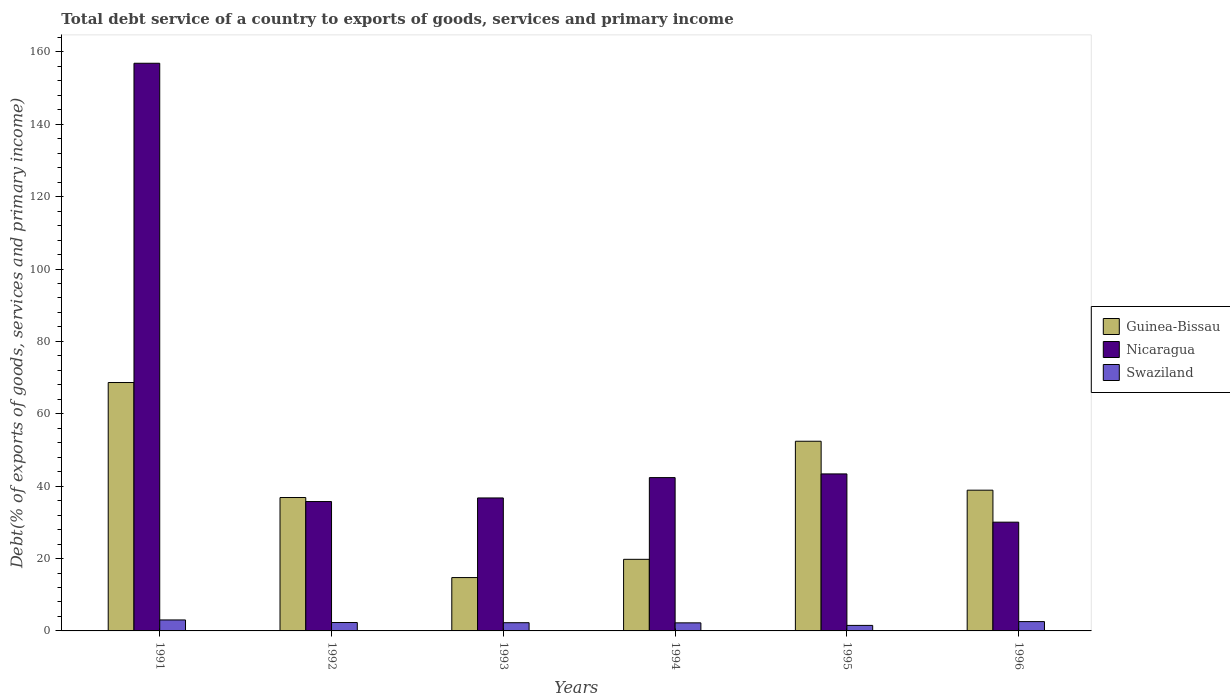How many different coloured bars are there?
Ensure brevity in your answer.  3. Are the number of bars per tick equal to the number of legend labels?
Give a very brief answer. Yes. How many bars are there on the 6th tick from the left?
Offer a terse response. 3. What is the total debt service in Swaziland in 1994?
Keep it short and to the point. 2.23. Across all years, what is the maximum total debt service in Nicaragua?
Give a very brief answer. 156.86. Across all years, what is the minimum total debt service in Swaziland?
Your response must be concise. 1.53. In which year was the total debt service in Swaziland maximum?
Offer a very short reply. 1991. What is the total total debt service in Nicaragua in the graph?
Offer a terse response. 345.16. What is the difference between the total debt service in Guinea-Bissau in 1992 and that in 1995?
Provide a short and direct response. -15.55. What is the difference between the total debt service in Swaziland in 1992 and the total debt service in Guinea-Bissau in 1993?
Offer a terse response. -12.42. What is the average total debt service in Guinea-Bissau per year?
Provide a succinct answer. 38.56. In the year 1993, what is the difference between the total debt service in Swaziland and total debt service in Guinea-Bissau?
Make the answer very short. -12.48. What is the ratio of the total debt service in Swaziland in 1992 to that in 1995?
Your answer should be very brief. 1.52. Is the total debt service in Guinea-Bissau in 1991 less than that in 1992?
Provide a succinct answer. No. Is the difference between the total debt service in Swaziland in 1991 and 1994 greater than the difference between the total debt service in Guinea-Bissau in 1991 and 1994?
Offer a terse response. No. What is the difference between the highest and the second highest total debt service in Nicaragua?
Provide a short and direct response. 113.47. What is the difference between the highest and the lowest total debt service in Swaziland?
Give a very brief answer. 1.51. Is the sum of the total debt service in Nicaragua in 1995 and 1996 greater than the maximum total debt service in Guinea-Bissau across all years?
Offer a very short reply. Yes. What does the 1st bar from the left in 1991 represents?
Make the answer very short. Guinea-Bissau. What does the 2nd bar from the right in 1993 represents?
Your answer should be compact. Nicaragua. Is it the case that in every year, the sum of the total debt service in Nicaragua and total debt service in Swaziland is greater than the total debt service in Guinea-Bissau?
Offer a very short reply. No. How many bars are there?
Provide a succinct answer. 18. Does the graph contain any zero values?
Your response must be concise. No. Does the graph contain grids?
Offer a very short reply. No. Where does the legend appear in the graph?
Provide a succinct answer. Center right. How are the legend labels stacked?
Offer a terse response. Vertical. What is the title of the graph?
Your answer should be very brief. Total debt service of a country to exports of goods, services and primary income. Does "Lesotho" appear as one of the legend labels in the graph?
Provide a succinct answer. No. What is the label or title of the Y-axis?
Give a very brief answer. Debt(% of exports of goods, services and primary income). What is the Debt(% of exports of goods, services and primary income) in Guinea-Bissau in 1991?
Offer a very short reply. 68.64. What is the Debt(% of exports of goods, services and primary income) in Nicaragua in 1991?
Make the answer very short. 156.86. What is the Debt(% of exports of goods, services and primary income) of Swaziland in 1991?
Provide a short and direct response. 3.03. What is the Debt(% of exports of goods, services and primary income) in Guinea-Bissau in 1992?
Offer a terse response. 36.86. What is the Debt(% of exports of goods, services and primary income) of Nicaragua in 1992?
Provide a succinct answer. 35.75. What is the Debt(% of exports of goods, services and primary income) of Swaziland in 1992?
Give a very brief answer. 2.32. What is the Debt(% of exports of goods, services and primary income) of Guinea-Bissau in 1993?
Offer a very short reply. 14.74. What is the Debt(% of exports of goods, services and primary income) of Nicaragua in 1993?
Your answer should be compact. 36.74. What is the Debt(% of exports of goods, services and primary income) in Swaziland in 1993?
Keep it short and to the point. 2.27. What is the Debt(% of exports of goods, services and primary income) of Guinea-Bissau in 1994?
Ensure brevity in your answer.  19.79. What is the Debt(% of exports of goods, services and primary income) of Nicaragua in 1994?
Offer a terse response. 42.37. What is the Debt(% of exports of goods, services and primary income) in Swaziland in 1994?
Offer a very short reply. 2.23. What is the Debt(% of exports of goods, services and primary income) in Guinea-Bissau in 1995?
Keep it short and to the point. 52.41. What is the Debt(% of exports of goods, services and primary income) in Nicaragua in 1995?
Keep it short and to the point. 43.39. What is the Debt(% of exports of goods, services and primary income) of Swaziland in 1995?
Offer a very short reply. 1.53. What is the Debt(% of exports of goods, services and primary income) of Guinea-Bissau in 1996?
Offer a very short reply. 38.89. What is the Debt(% of exports of goods, services and primary income) of Nicaragua in 1996?
Ensure brevity in your answer.  30.05. What is the Debt(% of exports of goods, services and primary income) in Swaziland in 1996?
Offer a terse response. 2.58. Across all years, what is the maximum Debt(% of exports of goods, services and primary income) in Guinea-Bissau?
Make the answer very short. 68.64. Across all years, what is the maximum Debt(% of exports of goods, services and primary income) in Nicaragua?
Keep it short and to the point. 156.86. Across all years, what is the maximum Debt(% of exports of goods, services and primary income) of Swaziland?
Make the answer very short. 3.03. Across all years, what is the minimum Debt(% of exports of goods, services and primary income) in Guinea-Bissau?
Offer a terse response. 14.74. Across all years, what is the minimum Debt(% of exports of goods, services and primary income) of Nicaragua?
Your response must be concise. 30.05. Across all years, what is the minimum Debt(% of exports of goods, services and primary income) in Swaziland?
Offer a terse response. 1.53. What is the total Debt(% of exports of goods, services and primary income) of Guinea-Bissau in the graph?
Provide a short and direct response. 231.33. What is the total Debt(% of exports of goods, services and primary income) of Nicaragua in the graph?
Provide a succinct answer. 345.16. What is the total Debt(% of exports of goods, services and primary income) in Swaziland in the graph?
Offer a very short reply. 13.95. What is the difference between the Debt(% of exports of goods, services and primary income) of Guinea-Bissau in 1991 and that in 1992?
Your response must be concise. 31.78. What is the difference between the Debt(% of exports of goods, services and primary income) in Nicaragua in 1991 and that in 1992?
Make the answer very short. 121.11. What is the difference between the Debt(% of exports of goods, services and primary income) in Swaziland in 1991 and that in 1992?
Your response must be concise. 0.71. What is the difference between the Debt(% of exports of goods, services and primary income) in Guinea-Bissau in 1991 and that in 1993?
Your response must be concise. 53.9. What is the difference between the Debt(% of exports of goods, services and primary income) of Nicaragua in 1991 and that in 1993?
Keep it short and to the point. 120.12. What is the difference between the Debt(% of exports of goods, services and primary income) of Swaziland in 1991 and that in 1993?
Your answer should be compact. 0.76. What is the difference between the Debt(% of exports of goods, services and primary income) of Guinea-Bissau in 1991 and that in 1994?
Offer a very short reply. 48.85. What is the difference between the Debt(% of exports of goods, services and primary income) in Nicaragua in 1991 and that in 1994?
Offer a very short reply. 114.49. What is the difference between the Debt(% of exports of goods, services and primary income) of Swaziland in 1991 and that in 1994?
Your answer should be compact. 0.81. What is the difference between the Debt(% of exports of goods, services and primary income) in Guinea-Bissau in 1991 and that in 1995?
Offer a terse response. 16.23. What is the difference between the Debt(% of exports of goods, services and primary income) of Nicaragua in 1991 and that in 1995?
Your response must be concise. 113.47. What is the difference between the Debt(% of exports of goods, services and primary income) in Swaziland in 1991 and that in 1995?
Keep it short and to the point. 1.5. What is the difference between the Debt(% of exports of goods, services and primary income) in Guinea-Bissau in 1991 and that in 1996?
Your response must be concise. 29.75. What is the difference between the Debt(% of exports of goods, services and primary income) in Nicaragua in 1991 and that in 1996?
Your response must be concise. 126.81. What is the difference between the Debt(% of exports of goods, services and primary income) of Swaziland in 1991 and that in 1996?
Your response must be concise. 0.46. What is the difference between the Debt(% of exports of goods, services and primary income) of Guinea-Bissau in 1992 and that in 1993?
Make the answer very short. 22.12. What is the difference between the Debt(% of exports of goods, services and primary income) of Nicaragua in 1992 and that in 1993?
Your answer should be very brief. -0.99. What is the difference between the Debt(% of exports of goods, services and primary income) in Swaziland in 1992 and that in 1993?
Offer a terse response. 0.05. What is the difference between the Debt(% of exports of goods, services and primary income) in Guinea-Bissau in 1992 and that in 1994?
Ensure brevity in your answer.  17.07. What is the difference between the Debt(% of exports of goods, services and primary income) in Nicaragua in 1992 and that in 1994?
Provide a succinct answer. -6.62. What is the difference between the Debt(% of exports of goods, services and primary income) in Swaziland in 1992 and that in 1994?
Provide a succinct answer. 0.09. What is the difference between the Debt(% of exports of goods, services and primary income) in Guinea-Bissau in 1992 and that in 1995?
Offer a very short reply. -15.55. What is the difference between the Debt(% of exports of goods, services and primary income) of Nicaragua in 1992 and that in 1995?
Your answer should be compact. -7.64. What is the difference between the Debt(% of exports of goods, services and primary income) in Swaziland in 1992 and that in 1995?
Ensure brevity in your answer.  0.79. What is the difference between the Debt(% of exports of goods, services and primary income) in Guinea-Bissau in 1992 and that in 1996?
Provide a short and direct response. -2.03. What is the difference between the Debt(% of exports of goods, services and primary income) of Nicaragua in 1992 and that in 1996?
Provide a succinct answer. 5.7. What is the difference between the Debt(% of exports of goods, services and primary income) of Swaziland in 1992 and that in 1996?
Ensure brevity in your answer.  -0.26. What is the difference between the Debt(% of exports of goods, services and primary income) in Guinea-Bissau in 1993 and that in 1994?
Give a very brief answer. -5.04. What is the difference between the Debt(% of exports of goods, services and primary income) of Nicaragua in 1993 and that in 1994?
Give a very brief answer. -5.62. What is the difference between the Debt(% of exports of goods, services and primary income) of Swaziland in 1993 and that in 1994?
Offer a very short reply. 0.04. What is the difference between the Debt(% of exports of goods, services and primary income) of Guinea-Bissau in 1993 and that in 1995?
Make the answer very short. -37.67. What is the difference between the Debt(% of exports of goods, services and primary income) of Nicaragua in 1993 and that in 1995?
Offer a very short reply. -6.64. What is the difference between the Debt(% of exports of goods, services and primary income) in Swaziland in 1993 and that in 1995?
Your answer should be very brief. 0.74. What is the difference between the Debt(% of exports of goods, services and primary income) of Guinea-Bissau in 1993 and that in 1996?
Your response must be concise. -24.15. What is the difference between the Debt(% of exports of goods, services and primary income) of Nicaragua in 1993 and that in 1996?
Provide a short and direct response. 6.69. What is the difference between the Debt(% of exports of goods, services and primary income) of Swaziland in 1993 and that in 1996?
Ensure brevity in your answer.  -0.31. What is the difference between the Debt(% of exports of goods, services and primary income) of Guinea-Bissau in 1994 and that in 1995?
Provide a short and direct response. -32.63. What is the difference between the Debt(% of exports of goods, services and primary income) of Nicaragua in 1994 and that in 1995?
Your answer should be very brief. -1.02. What is the difference between the Debt(% of exports of goods, services and primary income) in Guinea-Bissau in 1994 and that in 1996?
Your answer should be compact. -19.1. What is the difference between the Debt(% of exports of goods, services and primary income) in Nicaragua in 1994 and that in 1996?
Give a very brief answer. 12.32. What is the difference between the Debt(% of exports of goods, services and primary income) of Swaziland in 1994 and that in 1996?
Ensure brevity in your answer.  -0.35. What is the difference between the Debt(% of exports of goods, services and primary income) in Guinea-Bissau in 1995 and that in 1996?
Your answer should be compact. 13.52. What is the difference between the Debt(% of exports of goods, services and primary income) in Nicaragua in 1995 and that in 1996?
Make the answer very short. 13.33. What is the difference between the Debt(% of exports of goods, services and primary income) in Swaziland in 1995 and that in 1996?
Your answer should be compact. -1.05. What is the difference between the Debt(% of exports of goods, services and primary income) in Guinea-Bissau in 1991 and the Debt(% of exports of goods, services and primary income) in Nicaragua in 1992?
Give a very brief answer. 32.89. What is the difference between the Debt(% of exports of goods, services and primary income) in Guinea-Bissau in 1991 and the Debt(% of exports of goods, services and primary income) in Swaziland in 1992?
Offer a very short reply. 66.32. What is the difference between the Debt(% of exports of goods, services and primary income) of Nicaragua in 1991 and the Debt(% of exports of goods, services and primary income) of Swaziland in 1992?
Ensure brevity in your answer.  154.54. What is the difference between the Debt(% of exports of goods, services and primary income) of Guinea-Bissau in 1991 and the Debt(% of exports of goods, services and primary income) of Nicaragua in 1993?
Your answer should be very brief. 31.9. What is the difference between the Debt(% of exports of goods, services and primary income) in Guinea-Bissau in 1991 and the Debt(% of exports of goods, services and primary income) in Swaziland in 1993?
Provide a succinct answer. 66.37. What is the difference between the Debt(% of exports of goods, services and primary income) of Nicaragua in 1991 and the Debt(% of exports of goods, services and primary income) of Swaziland in 1993?
Your answer should be very brief. 154.59. What is the difference between the Debt(% of exports of goods, services and primary income) in Guinea-Bissau in 1991 and the Debt(% of exports of goods, services and primary income) in Nicaragua in 1994?
Keep it short and to the point. 26.27. What is the difference between the Debt(% of exports of goods, services and primary income) in Guinea-Bissau in 1991 and the Debt(% of exports of goods, services and primary income) in Swaziland in 1994?
Provide a short and direct response. 66.41. What is the difference between the Debt(% of exports of goods, services and primary income) in Nicaragua in 1991 and the Debt(% of exports of goods, services and primary income) in Swaziland in 1994?
Your answer should be very brief. 154.63. What is the difference between the Debt(% of exports of goods, services and primary income) in Guinea-Bissau in 1991 and the Debt(% of exports of goods, services and primary income) in Nicaragua in 1995?
Ensure brevity in your answer.  25.25. What is the difference between the Debt(% of exports of goods, services and primary income) of Guinea-Bissau in 1991 and the Debt(% of exports of goods, services and primary income) of Swaziland in 1995?
Offer a very short reply. 67.11. What is the difference between the Debt(% of exports of goods, services and primary income) in Nicaragua in 1991 and the Debt(% of exports of goods, services and primary income) in Swaziland in 1995?
Offer a very short reply. 155.33. What is the difference between the Debt(% of exports of goods, services and primary income) of Guinea-Bissau in 1991 and the Debt(% of exports of goods, services and primary income) of Nicaragua in 1996?
Your answer should be very brief. 38.59. What is the difference between the Debt(% of exports of goods, services and primary income) of Guinea-Bissau in 1991 and the Debt(% of exports of goods, services and primary income) of Swaziland in 1996?
Keep it short and to the point. 66.06. What is the difference between the Debt(% of exports of goods, services and primary income) of Nicaragua in 1991 and the Debt(% of exports of goods, services and primary income) of Swaziland in 1996?
Ensure brevity in your answer.  154.28. What is the difference between the Debt(% of exports of goods, services and primary income) in Guinea-Bissau in 1992 and the Debt(% of exports of goods, services and primary income) in Nicaragua in 1993?
Your response must be concise. 0.12. What is the difference between the Debt(% of exports of goods, services and primary income) in Guinea-Bissau in 1992 and the Debt(% of exports of goods, services and primary income) in Swaziland in 1993?
Ensure brevity in your answer.  34.59. What is the difference between the Debt(% of exports of goods, services and primary income) of Nicaragua in 1992 and the Debt(% of exports of goods, services and primary income) of Swaziland in 1993?
Offer a very short reply. 33.48. What is the difference between the Debt(% of exports of goods, services and primary income) in Guinea-Bissau in 1992 and the Debt(% of exports of goods, services and primary income) in Nicaragua in 1994?
Offer a terse response. -5.51. What is the difference between the Debt(% of exports of goods, services and primary income) in Guinea-Bissau in 1992 and the Debt(% of exports of goods, services and primary income) in Swaziland in 1994?
Give a very brief answer. 34.63. What is the difference between the Debt(% of exports of goods, services and primary income) of Nicaragua in 1992 and the Debt(% of exports of goods, services and primary income) of Swaziland in 1994?
Provide a succinct answer. 33.52. What is the difference between the Debt(% of exports of goods, services and primary income) in Guinea-Bissau in 1992 and the Debt(% of exports of goods, services and primary income) in Nicaragua in 1995?
Make the answer very short. -6.53. What is the difference between the Debt(% of exports of goods, services and primary income) of Guinea-Bissau in 1992 and the Debt(% of exports of goods, services and primary income) of Swaziland in 1995?
Offer a very short reply. 35.33. What is the difference between the Debt(% of exports of goods, services and primary income) of Nicaragua in 1992 and the Debt(% of exports of goods, services and primary income) of Swaziland in 1995?
Keep it short and to the point. 34.22. What is the difference between the Debt(% of exports of goods, services and primary income) of Guinea-Bissau in 1992 and the Debt(% of exports of goods, services and primary income) of Nicaragua in 1996?
Your answer should be very brief. 6.81. What is the difference between the Debt(% of exports of goods, services and primary income) of Guinea-Bissau in 1992 and the Debt(% of exports of goods, services and primary income) of Swaziland in 1996?
Make the answer very short. 34.28. What is the difference between the Debt(% of exports of goods, services and primary income) in Nicaragua in 1992 and the Debt(% of exports of goods, services and primary income) in Swaziland in 1996?
Offer a very short reply. 33.17. What is the difference between the Debt(% of exports of goods, services and primary income) of Guinea-Bissau in 1993 and the Debt(% of exports of goods, services and primary income) of Nicaragua in 1994?
Your answer should be compact. -27.62. What is the difference between the Debt(% of exports of goods, services and primary income) of Guinea-Bissau in 1993 and the Debt(% of exports of goods, services and primary income) of Swaziland in 1994?
Provide a succinct answer. 12.52. What is the difference between the Debt(% of exports of goods, services and primary income) in Nicaragua in 1993 and the Debt(% of exports of goods, services and primary income) in Swaziland in 1994?
Your answer should be compact. 34.51. What is the difference between the Debt(% of exports of goods, services and primary income) in Guinea-Bissau in 1993 and the Debt(% of exports of goods, services and primary income) in Nicaragua in 1995?
Offer a very short reply. -28.64. What is the difference between the Debt(% of exports of goods, services and primary income) of Guinea-Bissau in 1993 and the Debt(% of exports of goods, services and primary income) of Swaziland in 1995?
Keep it short and to the point. 13.22. What is the difference between the Debt(% of exports of goods, services and primary income) in Nicaragua in 1993 and the Debt(% of exports of goods, services and primary income) in Swaziland in 1995?
Provide a succinct answer. 35.21. What is the difference between the Debt(% of exports of goods, services and primary income) in Guinea-Bissau in 1993 and the Debt(% of exports of goods, services and primary income) in Nicaragua in 1996?
Ensure brevity in your answer.  -15.31. What is the difference between the Debt(% of exports of goods, services and primary income) of Guinea-Bissau in 1993 and the Debt(% of exports of goods, services and primary income) of Swaziland in 1996?
Give a very brief answer. 12.17. What is the difference between the Debt(% of exports of goods, services and primary income) of Nicaragua in 1993 and the Debt(% of exports of goods, services and primary income) of Swaziland in 1996?
Offer a very short reply. 34.17. What is the difference between the Debt(% of exports of goods, services and primary income) in Guinea-Bissau in 1994 and the Debt(% of exports of goods, services and primary income) in Nicaragua in 1995?
Offer a terse response. -23.6. What is the difference between the Debt(% of exports of goods, services and primary income) in Guinea-Bissau in 1994 and the Debt(% of exports of goods, services and primary income) in Swaziland in 1995?
Your answer should be very brief. 18.26. What is the difference between the Debt(% of exports of goods, services and primary income) of Nicaragua in 1994 and the Debt(% of exports of goods, services and primary income) of Swaziland in 1995?
Provide a short and direct response. 40.84. What is the difference between the Debt(% of exports of goods, services and primary income) of Guinea-Bissau in 1994 and the Debt(% of exports of goods, services and primary income) of Nicaragua in 1996?
Your response must be concise. -10.27. What is the difference between the Debt(% of exports of goods, services and primary income) of Guinea-Bissau in 1994 and the Debt(% of exports of goods, services and primary income) of Swaziland in 1996?
Provide a succinct answer. 17.21. What is the difference between the Debt(% of exports of goods, services and primary income) of Nicaragua in 1994 and the Debt(% of exports of goods, services and primary income) of Swaziland in 1996?
Ensure brevity in your answer.  39.79. What is the difference between the Debt(% of exports of goods, services and primary income) in Guinea-Bissau in 1995 and the Debt(% of exports of goods, services and primary income) in Nicaragua in 1996?
Your response must be concise. 22.36. What is the difference between the Debt(% of exports of goods, services and primary income) of Guinea-Bissau in 1995 and the Debt(% of exports of goods, services and primary income) of Swaziland in 1996?
Provide a short and direct response. 49.84. What is the difference between the Debt(% of exports of goods, services and primary income) in Nicaragua in 1995 and the Debt(% of exports of goods, services and primary income) in Swaziland in 1996?
Your answer should be compact. 40.81. What is the average Debt(% of exports of goods, services and primary income) in Guinea-Bissau per year?
Make the answer very short. 38.56. What is the average Debt(% of exports of goods, services and primary income) in Nicaragua per year?
Provide a short and direct response. 57.53. What is the average Debt(% of exports of goods, services and primary income) of Swaziland per year?
Provide a short and direct response. 2.33. In the year 1991, what is the difference between the Debt(% of exports of goods, services and primary income) of Guinea-Bissau and Debt(% of exports of goods, services and primary income) of Nicaragua?
Your response must be concise. -88.22. In the year 1991, what is the difference between the Debt(% of exports of goods, services and primary income) of Guinea-Bissau and Debt(% of exports of goods, services and primary income) of Swaziland?
Offer a very short reply. 65.61. In the year 1991, what is the difference between the Debt(% of exports of goods, services and primary income) in Nicaragua and Debt(% of exports of goods, services and primary income) in Swaziland?
Make the answer very short. 153.83. In the year 1992, what is the difference between the Debt(% of exports of goods, services and primary income) in Guinea-Bissau and Debt(% of exports of goods, services and primary income) in Nicaragua?
Ensure brevity in your answer.  1.11. In the year 1992, what is the difference between the Debt(% of exports of goods, services and primary income) of Guinea-Bissau and Debt(% of exports of goods, services and primary income) of Swaziland?
Provide a short and direct response. 34.54. In the year 1992, what is the difference between the Debt(% of exports of goods, services and primary income) of Nicaragua and Debt(% of exports of goods, services and primary income) of Swaziland?
Make the answer very short. 33.43. In the year 1993, what is the difference between the Debt(% of exports of goods, services and primary income) of Guinea-Bissau and Debt(% of exports of goods, services and primary income) of Nicaragua?
Ensure brevity in your answer.  -22. In the year 1993, what is the difference between the Debt(% of exports of goods, services and primary income) in Guinea-Bissau and Debt(% of exports of goods, services and primary income) in Swaziland?
Make the answer very short. 12.48. In the year 1993, what is the difference between the Debt(% of exports of goods, services and primary income) in Nicaragua and Debt(% of exports of goods, services and primary income) in Swaziland?
Offer a terse response. 34.47. In the year 1994, what is the difference between the Debt(% of exports of goods, services and primary income) in Guinea-Bissau and Debt(% of exports of goods, services and primary income) in Nicaragua?
Offer a terse response. -22.58. In the year 1994, what is the difference between the Debt(% of exports of goods, services and primary income) in Guinea-Bissau and Debt(% of exports of goods, services and primary income) in Swaziland?
Your answer should be compact. 17.56. In the year 1994, what is the difference between the Debt(% of exports of goods, services and primary income) in Nicaragua and Debt(% of exports of goods, services and primary income) in Swaziland?
Give a very brief answer. 40.14. In the year 1995, what is the difference between the Debt(% of exports of goods, services and primary income) of Guinea-Bissau and Debt(% of exports of goods, services and primary income) of Nicaragua?
Offer a terse response. 9.03. In the year 1995, what is the difference between the Debt(% of exports of goods, services and primary income) of Guinea-Bissau and Debt(% of exports of goods, services and primary income) of Swaziland?
Offer a very short reply. 50.89. In the year 1995, what is the difference between the Debt(% of exports of goods, services and primary income) of Nicaragua and Debt(% of exports of goods, services and primary income) of Swaziland?
Offer a very short reply. 41.86. In the year 1996, what is the difference between the Debt(% of exports of goods, services and primary income) in Guinea-Bissau and Debt(% of exports of goods, services and primary income) in Nicaragua?
Provide a short and direct response. 8.84. In the year 1996, what is the difference between the Debt(% of exports of goods, services and primary income) of Guinea-Bissau and Debt(% of exports of goods, services and primary income) of Swaziland?
Make the answer very short. 36.31. In the year 1996, what is the difference between the Debt(% of exports of goods, services and primary income) of Nicaragua and Debt(% of exports of goods, services and primary income) of Swaziland?
Make the answer very short. 27.47. What is the ratio of the Debt(% of exports of goods, services and primary income) of Guinea-Bissau in 1991 to that in 1992?
Provide a short and direct response. 1.86. What is the ratio of the Debt(% of exports of goods, services and primary income) in Nicaragua in 1991 to that in 1992?
Your answer should be compact. 4.39. What is the ratio of the Debt(% of exports of goods, services and primary income) of Swaziland in 1991 to that in 1992?
Offer a very short reply. 1.31. What is the ratio of the Debt(% of exports of goods, services and primary income) of Guinea-Bissau in 1991 to that in 1993?
Provide a succinct answer. 4.66. What is the ratio of the Debt(% of exports of goods, services and primary income) of Nicaragua in 1991 to that in 1993?
Provide a succinct answer. 4.27. What is the ratio of the Debt(% of exports of goods, services and primary income) of Swaziland in 1991 to that in 1993?
Your answer should be compact. 1.34. What is the ratio of the Debt(% of exports of goods, services and primary income) in Guinea-Bissau in 1991 to that in 1994?
Your response must be concise. 3.47. What is the ratio of the Debt(% of exports of goods, services and primary income) of Nicaragua in 1991 to that in 1994?
Your response must be concise. 3.7. What is the ratio of the Debt(% of exports of goods, services and primary income) of Swaziland in 1991 to that in 1994?
Keep it short and to the point. 1.36. What is the ratio of the Debt(% of exports of goods, services and primary income) in Guinea-Bissau in 1991 to that in 1995?
Offer a terse response. 1.31. What is the ratio of the Debt(% of exports of goods, services and primary income) in Nicaragua in 1991 to that in 1995?
Your answer should be compact. 3.62. What is the ratio of the Debt(% of exports of goods, services and primary income) of Swaziland in 1991 to that in 1995?
Offer a terse response. 1.99. What is the ratio of the Debt(% of exports of goods, services and primary income) in Guinea-Bissau in 1991 to that in 1996?
Provide a short and direct response. 1.76. What is the ratio of the Debt(% of exports of goods, services and primary income) of Nicaragua in 1991 to that in 1996?
Make the answer very short. 5.22. What is the ratio of the Debt(% of exports of goods, services and primary income) in Swaziland in 1991 to that in 1996?
Provide a short and direct response. 1.18. What is the ratio of the Debt(% of exports of goods, services and primary income) in Guinea-Bissau in 1992 to that in 1993?
Offer a terse response. 2.5. What is the ratio of the Debt(% of exports of goods, services and primary income) of Nicaragua in 1992 to that in 1993?
Your response must be concise. 0.97. What is the ratio of the Debt(% of exports of goods, services and primary income) in Swaziland in 1992 to that in 1993?
Your response must be concise. 1.02. What is the ratio of the Debt(% of exports of goods, services and primary income) in Guinea-Bissau in 1992 to that in 1994?
Provide a short and direct response. 1.86. What is the ratio of the Debt(% of exports of goods, services and primary income) of Nicaragua in 1992 to that in 1994?
Offer a terse response. 0.84. What is the ratio of the Debt(% of exports of goods, services and primary income) of Swaziland in 1992 to that in 1994?
Provide a short and direct response. 1.04. What is the ratio of the Debt(% of exports of goods, services and primary income) in Guinea-Bissau in 1992 to that in 1995?
Ensure brevity in your answer.  0.7. What is the ratio of the Debt(% of exports of goods, services and primary income) in Nicaragua in 1992 to that in 1995?
Provide a succinct answer. 0.82. What is the ratio of the Debt(% of exports of goods, services and primary income) in Swaziland in 1992 to that in 1995?
Your response must be concise. 1.52. What is the ratio of the Debt(% of exports of goods, services and primary income) in Guinea-Bissau in 1992 to that in 1996?
Your answer should be compact. 0.95. What is the ratio of the Debt(% of exports of goods, services and primary income) of Nicaragua in 1992 to that in 1996?
Your answer should be compact. 1.19. What is the ratio of the Debt(% of exports of goods, services and primary income) of Swaziland in 1992 to that in 1996?
Keep it short and to the point. 0.9. What is the ratio of the Debt(% of exports of goods, services and primary income) in Guinea-Bissau in 1993 to that in 1994?
Make the answer very short. 0.75. What is the ratio of the Debt(% of exports of goods, services and primary income) of Nicaragua in 1993 to that in 1994?
Offer a very short reply. 0.87. What is the ratio of the Debt(% of exports of goods, services and primary income) of Guinea-Bissau in 1993 to that in 1995?
Make the answer very short. 0.28. What is the ratio of the Debt(% of exports of goods, services and primary income) of Nicaragua in 1993 to that in 1995?
Keep it short and to the point. 0.85. What is the ratio of the Debt(% of exports of goods, services and primary income) in Swaziland in 1993 to that in 1995?
Offer a very short reply. 1.48. What is the ratio of the Debt(% of exports of goods, services and primary income) in Guinea-Bissau in 1993 to that in 1996?
Your response must be concise. 0.38. What is the ratio of the Debt(% of exports of goods, services and primary income) in Nicaragua in 1993 to that in 1996?
Ensure brevity in your answer.  1.22. What is the ratio of the Debt(% of exports of goods, services and primary income) in Guinea-Bissau in 1994 to that in 1995?
Offer a terse response. 0.38. What is the ratio of the Debt(% of exports of goods, services and primary income) of Nicaragua in 1994 to that in 1995?
Provide a succinct answer. 0.98. What is the ratio of the Debt(% of exports of goods, services and primary income) in Swaziland in 1994 to that in 1995?
Offer a very short reply. 1.46. What is the ratio of the Debt(% of exports of goods, services and primary income) of Guinea-Bissau in 1994 to that in 1996?
Your answer should be very brief. 0.51. What is the ratio of the Debt(% of exports of goods, services and primary income) of Nicaragua in 1994 to that in 1996?
Provide a short and direct response. 1.41. What is the ratio of the Debt(% of exports of goods, services and primary income) in Swaziland in 1994 to that in 1996?
Your response must be concise. 0.86. What is the ratio of the Debt(% of exports of goods, services and primary income) of Guinea-Bissau in 1995 to that in 1996?
Ensure brevity in your answer.  1.35. What is the ratio of the Debt(% of exports of goods, services and primary income) in Nicaragua in 1995 to that in 1996?
Your answer should be compact. 1.44. What is the ratio of the Debt(% of exports of goods, services and primary income) of Swaziland in 1995 to that in 1996?
Your response must be concise. 0.59. What is the difference between the highest and the second highest Debt(% of exports of goods, services and primary income) in Guinea-Bissau?
Keep it short and to the point. 16.23. What is the difference between the highest and the second highest Debt(% of exports of goods, services and primary income) in Nicaragua?
Your answer should be compact. 113.47. What is the difference between the highest and the second highest Debt(% of exports of goods, services and primary income) of Swaziland?
Provide a succinct answer. 0.46. What is the difference between the highest and the lowest Debt(% of exports of goods, services and primary income) of Guinea-Bissau?
Provide a short and direct response. 53.9. What is the difference between the highest and the lowest Debt(% of exports of goods, services and primary income) in Nicaragua?
Your answer should be compact. 126.81. What is the difference between the highest and the lowest Debt(% of exports of goods, services and primary income) of Swaziland?
Offer a very short reply. 1.5. 